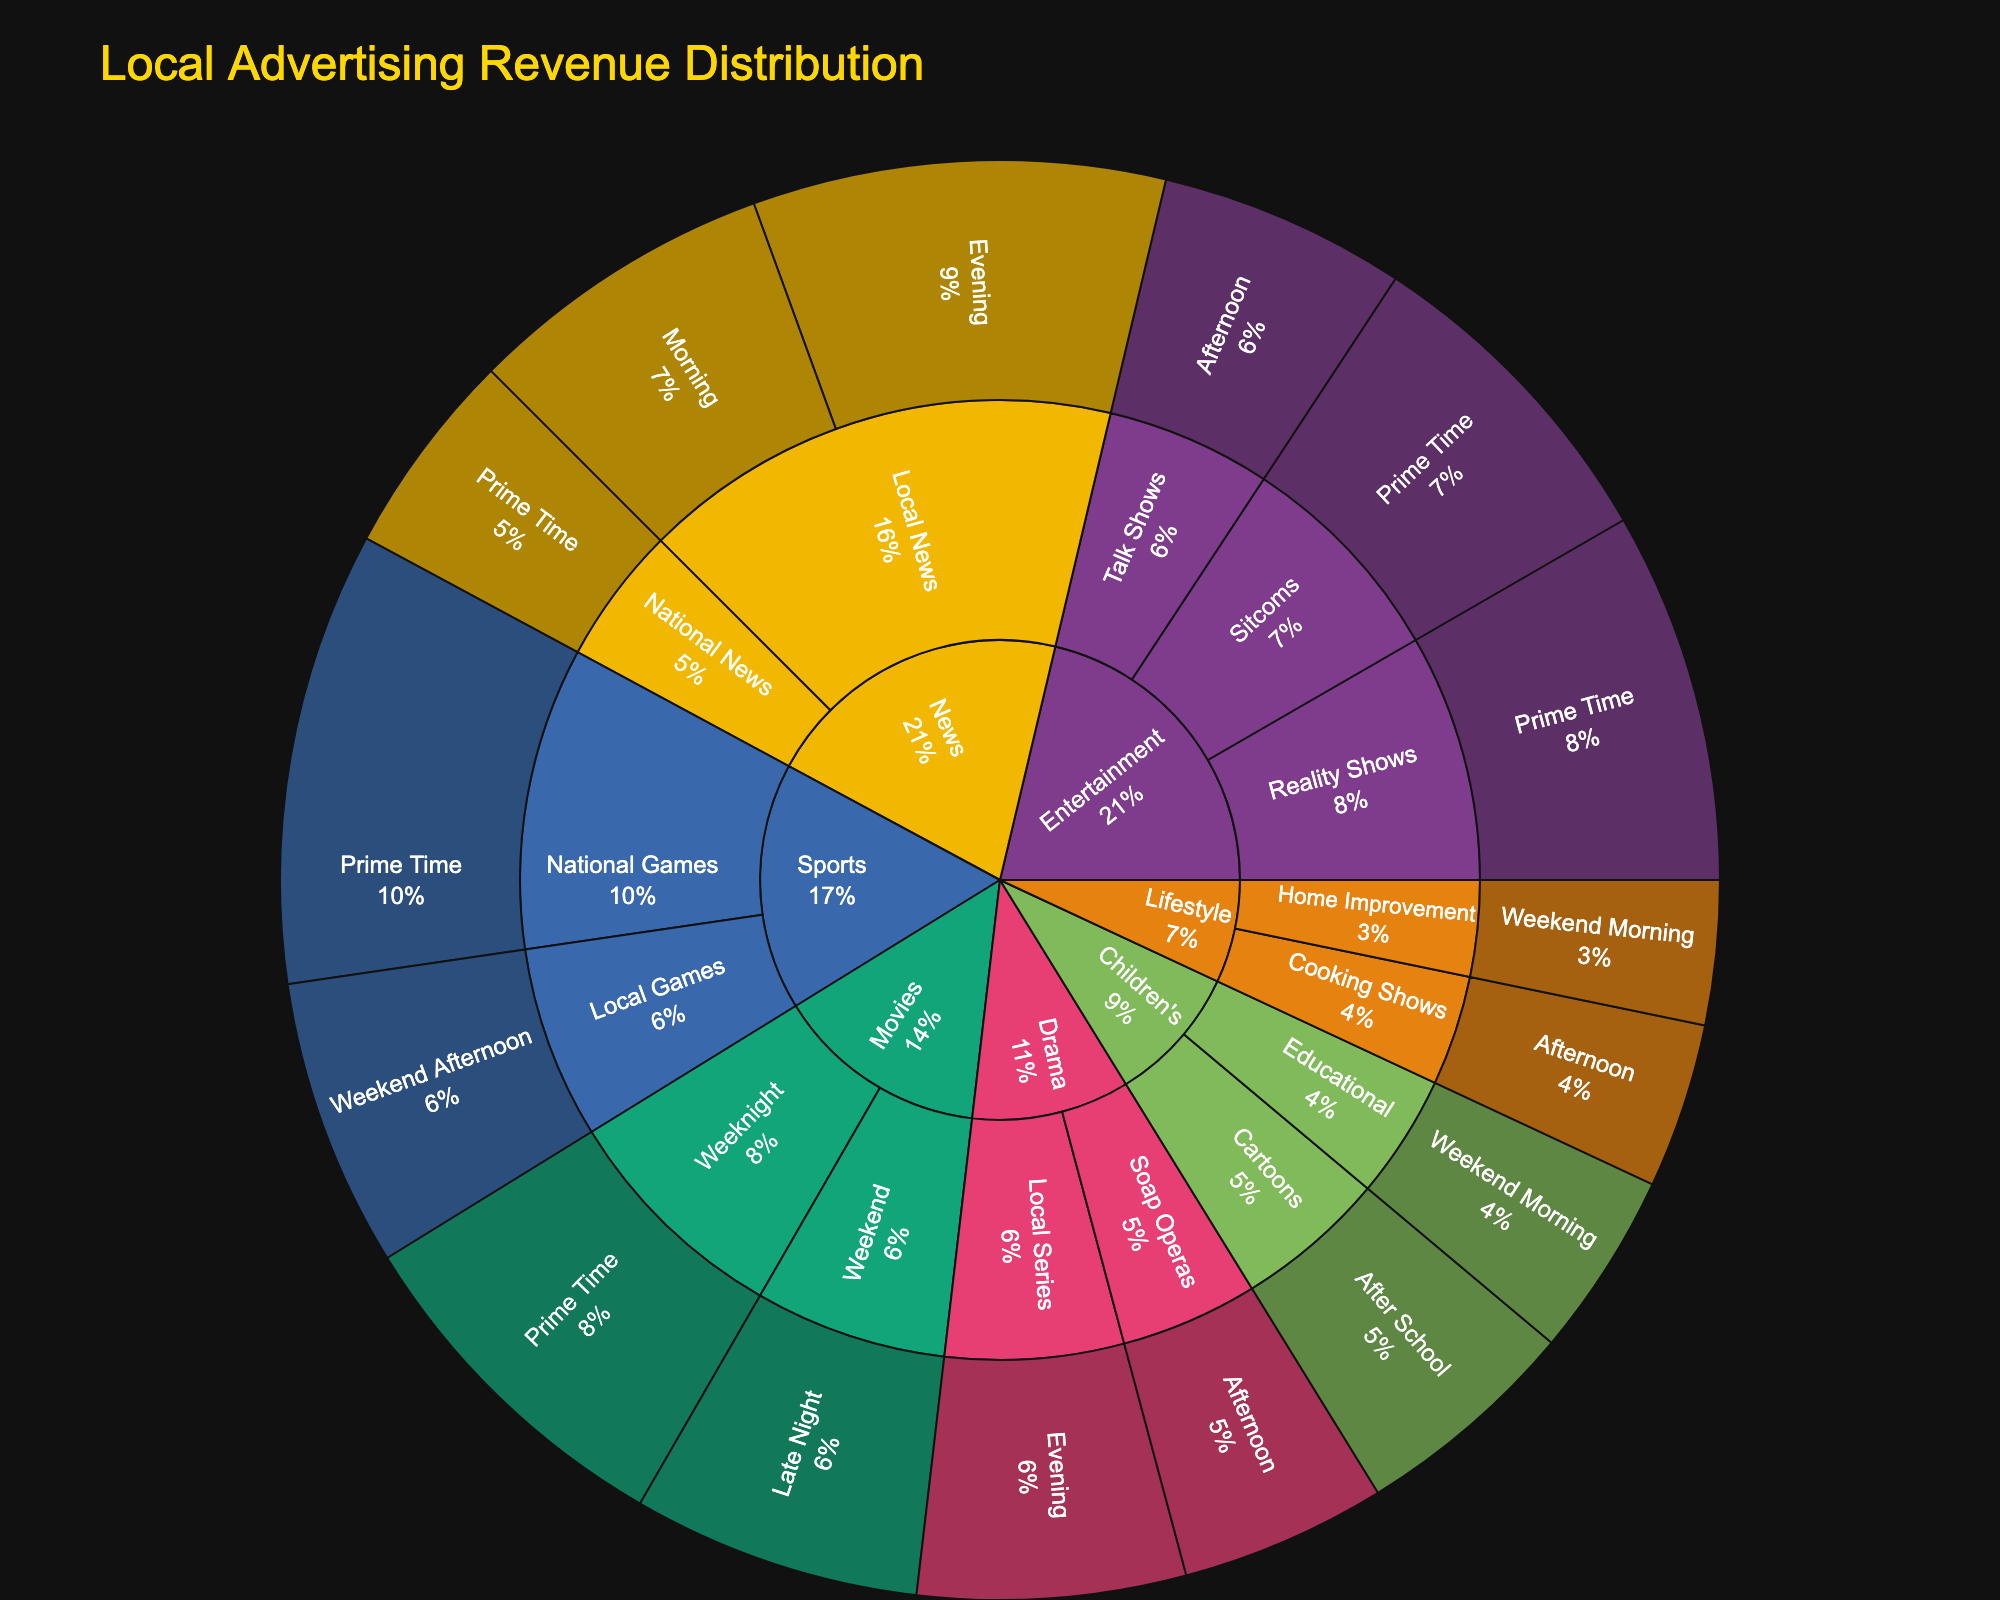what is the title of the plot? The title is often found at the top of the plot and summarizes the visual content. In this case, the title displayed is directly from the plot generation parameters.
Answer: Local Advertising Revenue Distribution How much revenue does News category generate in the Morning timeslot? The revenue for the News category in the Morning timeslot can be found by locating the "News" sector and then tracing to the “Local News” and “Morning” sub-sectors.
Answer: $150,000 Which category has the highest revenue during Prime Time? To find this, trace the sub-sectors under Prime Time. Compare the revenues of News ($100,000), Reality Shows ($180,000), Sitcoms ($160,000), National Games ($220,000), and Weeknight Movies ($170,000).
Answer: Sports (National Games) What is the total revenue for the Entertainment category? Sum the revenues of all subcategories in Entertainment: Reality Shows ($180,000) + Sitcoms ($160,000) + Talk Shows ($120,000).
Answer: $460,000 What's the combined revenue of both the Children's category in After School and Weekend Morning timeslots? Sum the revenues of Children's (Cartoons, After School) and Children's (Educational, Weekend Morning).
Answer: $110,000 + $90,000 = $200,000 Which timeslot has the highest revenue in the Children’s category? Compare the revenues of After School (Cartoons) and Weekend Morning (Educational).
Answer: After School How does the revenue from Drama (Evening) compare to that from Drama (Afternoon)? Compare the revenue of the Drama category for Evening (Local Series) and Afternoon (Soap Operas). Evening generates $130,000 and Afternoon generates $100,000.
Answer: Evening is higher What is the revenue distribution of the Lifestyle category across its timeslots? Check the revenues for Lifestyle sub-sectors: Afternoon (Cooking Shows) has $80,000 and Weekend Morning (Home Improvement) has $70,000.
Answer: $80,000 in Afternoon, $70,000 in Weekend Morning What proportion of total revenue comes from the News category’s Evening timeslot? First, find the total revenue summation across all categories, then calculate the fraction that News (Evening) represents. Sum of all revenues is $2,090,000 and News (Evening) is $200,000.
Answer: 200,000/2,090,000 ≈ 9.57% Which subcategory in Entertainment generates more revenue: Reality Shows or Sitcoms? Compare the revenue of Reality Shows and Sitcoms in Entertainment sector from the plot. Reality Shows generate $180,000 and Sitcoms generate $160,000.
Answer: Reality Shows 